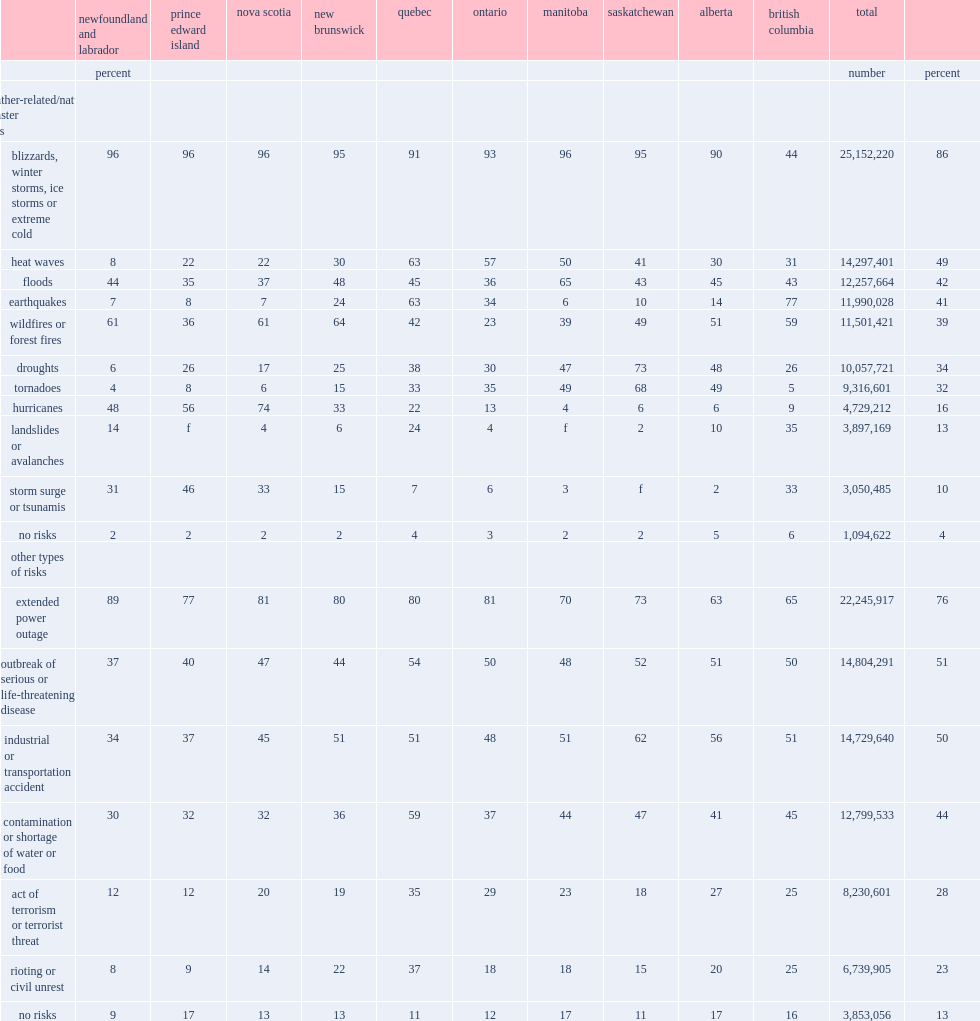According to the 2014 sepr, what is the percentage of canadians' communities at greatest risk of facing winter storms? 86.0. The exception was those living in british columbia, what is the percentage of earthquakes most frequently identified as a potential risk? 77.0. What is the percentage of wildfires named as the second most common risk in new brunswick in 2014? 64.0. What is the percentage of wildfires named as the second most common risk in newfoundland and labrador in 2014? 61.0. What is the percentage of wildfires named as the second most common risk in british columbia in 2014? 59.0. What is the percentage of wildfires named as the second most common risk in alberta in 2014? 51.0. What is the percentage of floods risk in manitoba in 2014? 65.0. What is the percentage of droughts risk in saskatchewan in 2014? 73.0. What is the percentage of hurricanes risk in nova scotia in 2014? 74.0. What is the percentage of hurricanes risk in prince edward island in 2014? 56.0. In ontario, what the percentage was heat waves in 2014? 57.0. In quebec, what the percentage was heat waves in 2014? 63.0. In quebec, what the percentage was earthquakes in 2014? 63.0. 